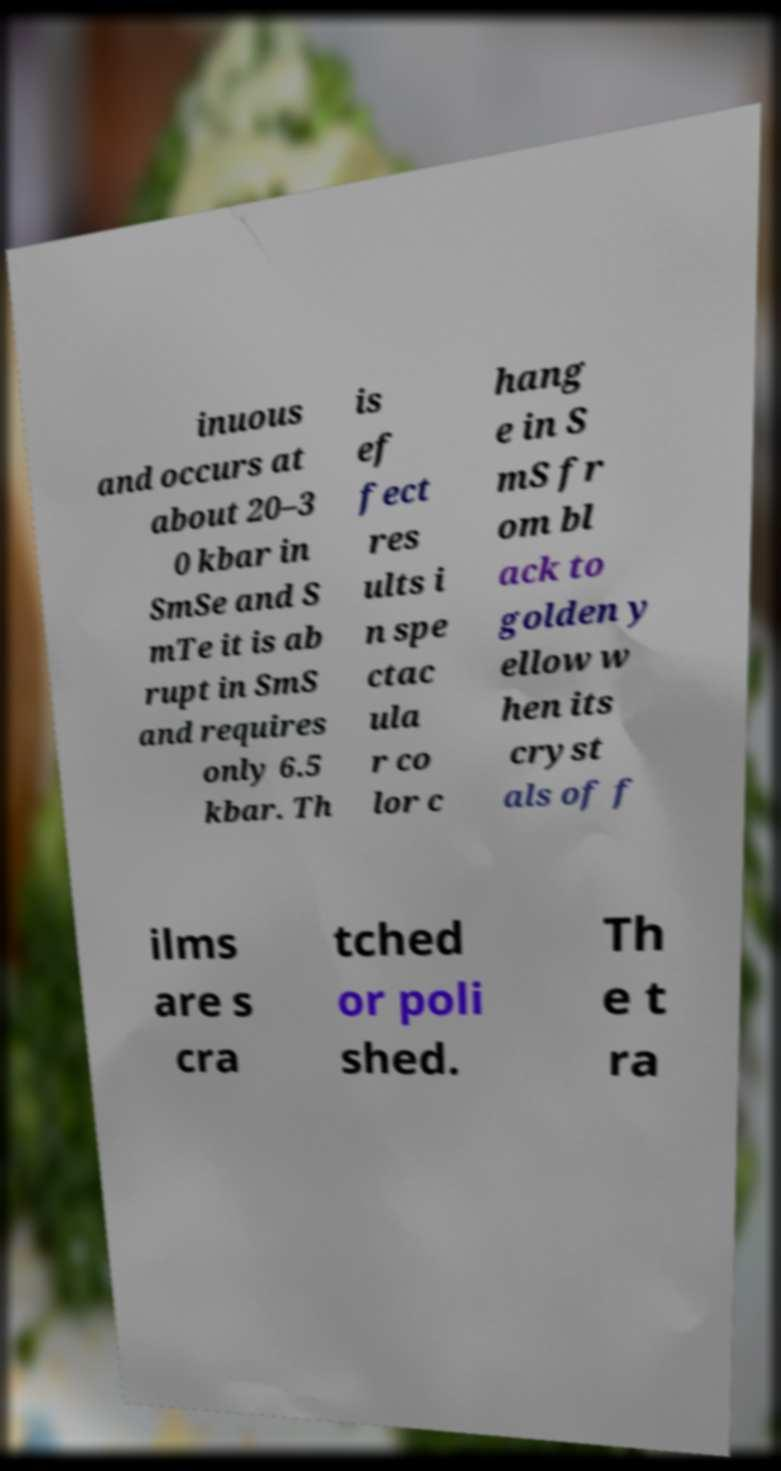For documentation purposes, I need the text within this image transcribed. Could you provide that? inuous and occurs at about 20–3 0 kbar in SmSe and S mTe it is ab rupt in SmS and requires only 6.5 kbar. Th is ef fect res ults i n spe ctac ula r co lor c hang e in S mS fr om bl ack to golden y ellow w hen its cryst als of f ilms are s cra tched or poli shed. Th e t ra 